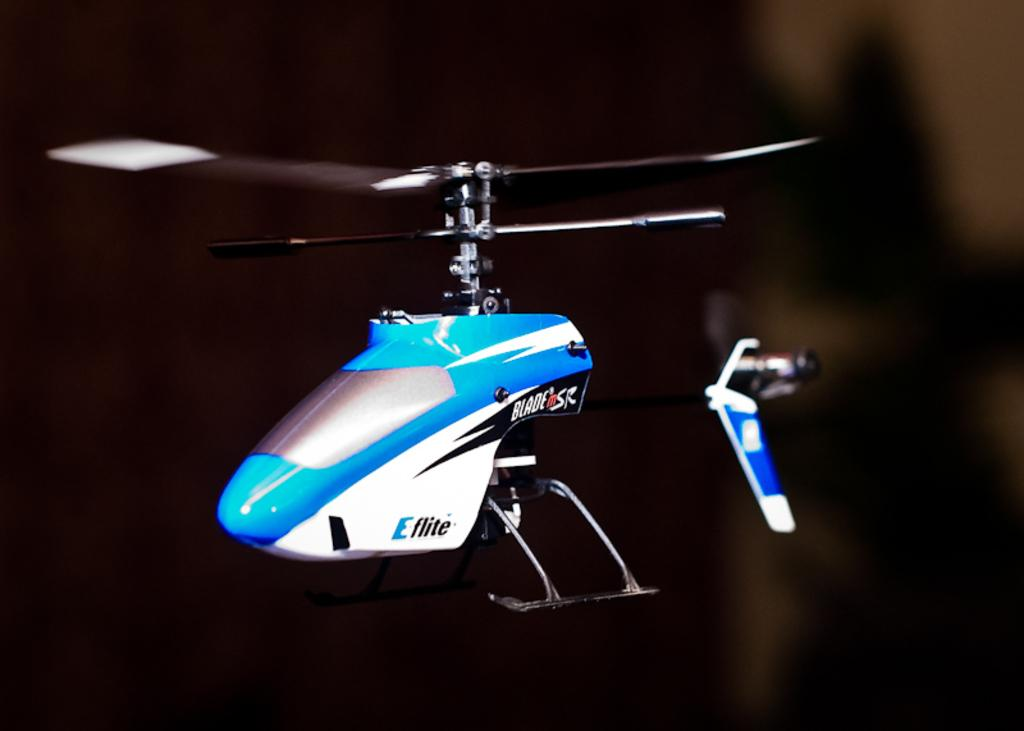What is the main subject of the image? The main subject of the image is a flying jet. What colors can be seen on the jet? The jet is white, blue, and black in color. How would you describe the background of the image? The background of the image is blurred. How many pies are being carried by the jet in the image? There are no pies visible in the image; the jet is the main subject. 